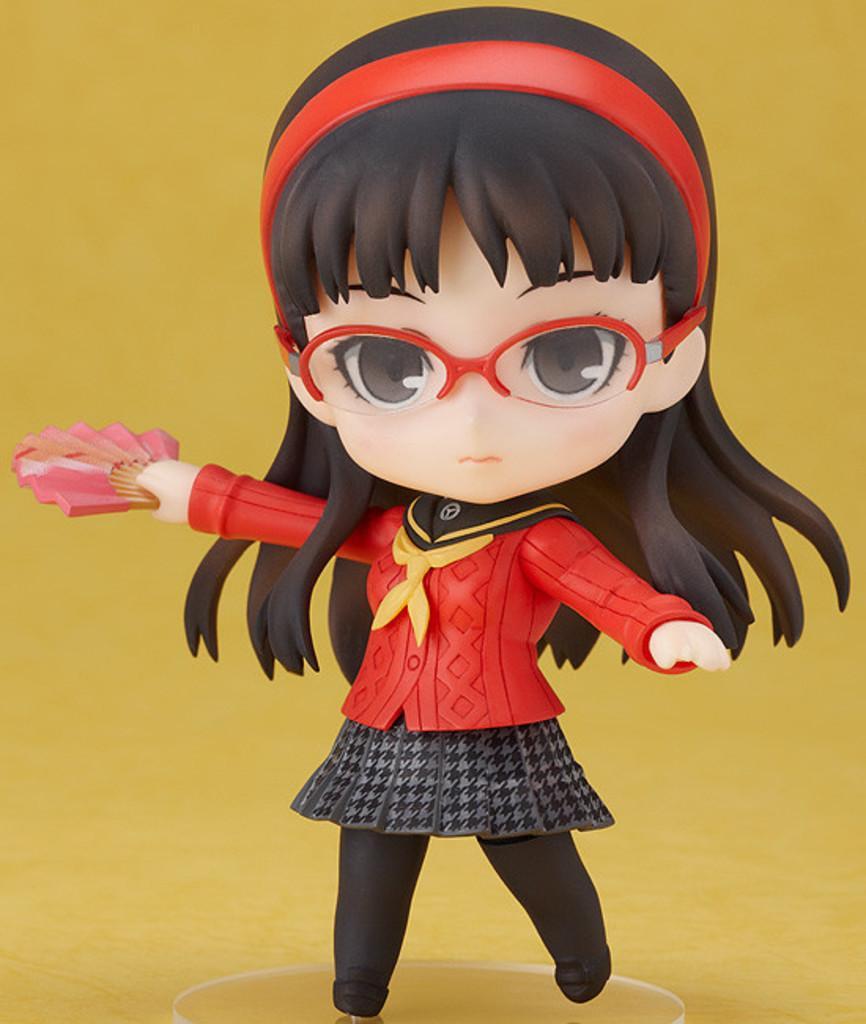Describe this image in one or two sentences. In this image I can see the toy wearing the dress red, black and ash color. I can also see the specs to the toy. And there is a yellow background. 